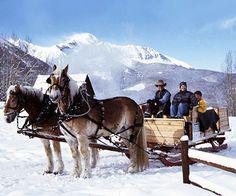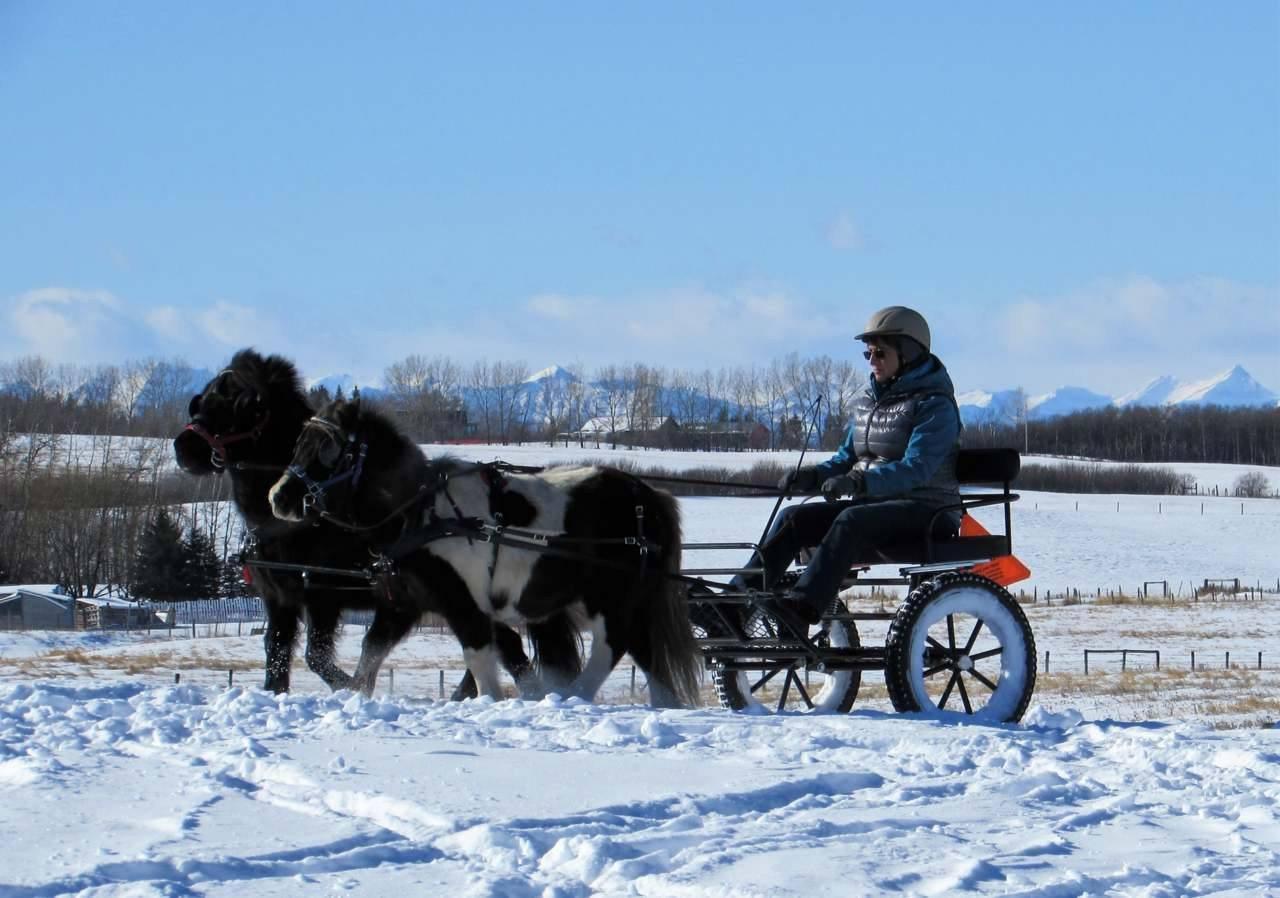The first image is the image on the left, the second image is the image on the right. Assess this claim about the two images: "An image shows a four-wheeled horse-drawn wagon with some type of white canopy.". Correct or not? Answer yes or no. No. The first image is the image on the left, the second image is the image on the right. For the images displayed, is the sentence "A white horse is pulling one of the carts." factually correct? Answer yes or no. No. 